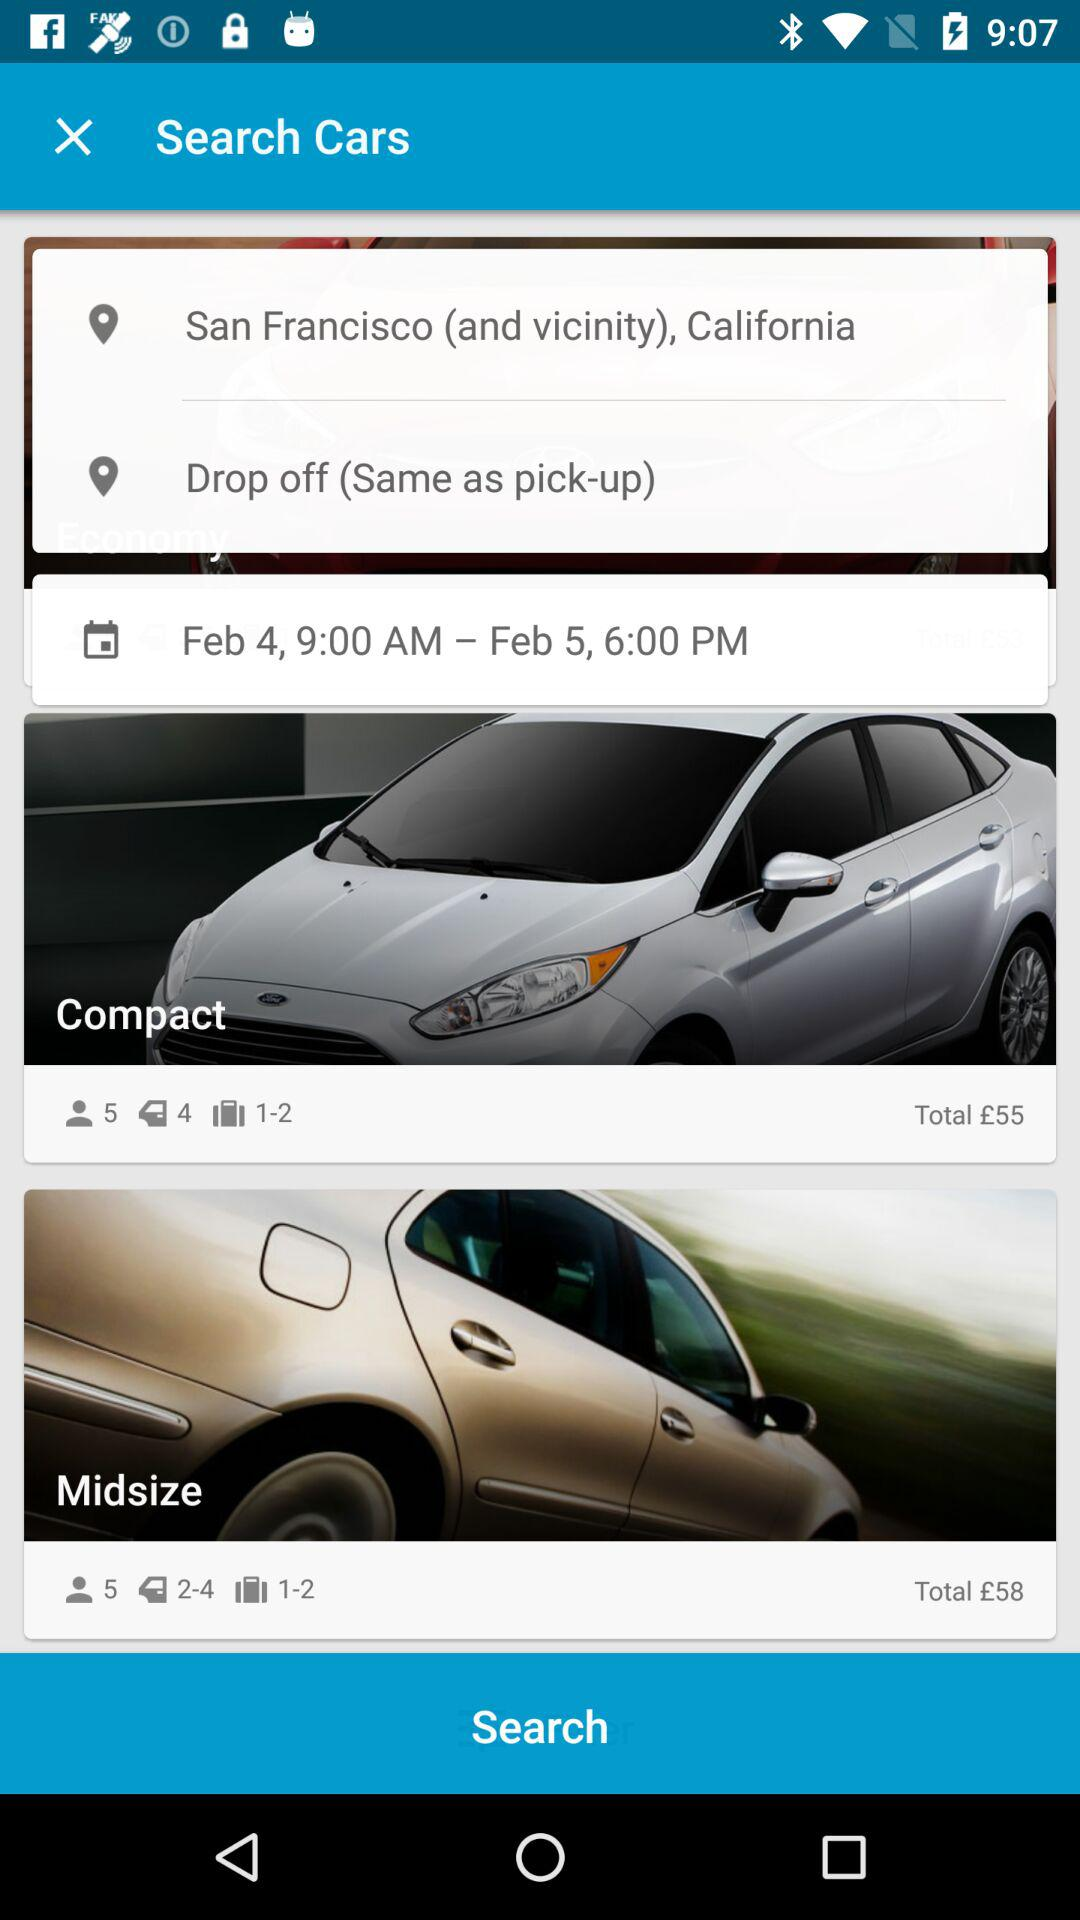How much is the compact car in USD?
When the provided information is insufficient, respond with <no answer>. <no answer> 